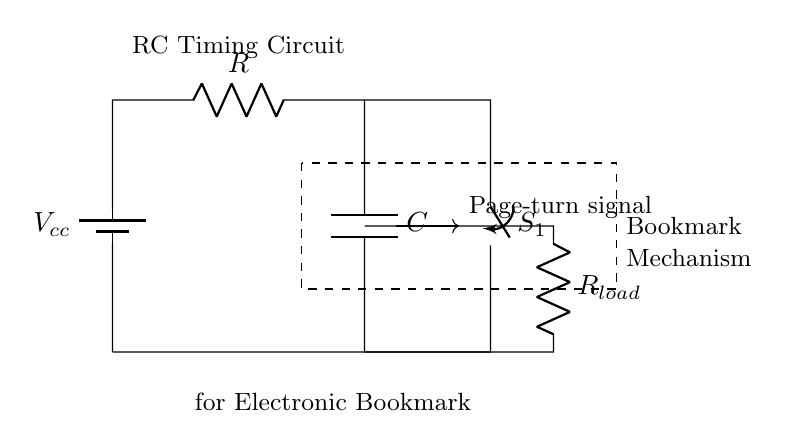What is the function of the capacitor in this circuit? The capacitor in this RC timing circuit stores charge and is crucial for timing, controlling how long the page-turning signal lasts before it dissipates.
Answer: Stores charge What type of switch is shown in the diagram? The diagram shows a mechanical switch labeled as S1, which can open or close the circuit to allow or interrupt current flow.
Answer: Mechanical What is the role of resistor R in the circuit? Resistor R regulates the current flow in the circuit, affecting the charging rate of the capacitor and thus influencing the timing interval for the page-turning mechanism.
Answer: Regulates current What happens when the switch S1 is closed? When S1 is closed, the circuit completes, allowing current to flow through R and charge C, producing the page-turn signal that activates the page-turning mechanism.
Answer: Activates signal How does the load resistor R_load affect the circuit? The load resistor R_load affects the voltage drop across it when the circuit is active, which can influence the delivery and duration of the page-turning signal based on the current through the load.
Answer: Influences signal duration What is the purpose of the dashed rectangle in the diagram? The dashed rectangle encloses the components related to the bookmark mechanism, indicating its separation from the power sources and its role in the overall function of the circuit.
Answer: Encloses mechanism What is the voltage source used in this circuit? The voltage source used is labeled V_cc, which supplies the necessary voltage to power the circuit and components involved in automatic page-turning.
Answer: V_cc 